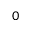Convert formula to latex. <formula><loc_0><loc_0><loc_500><loc_500>_ { 0 }</formula> 